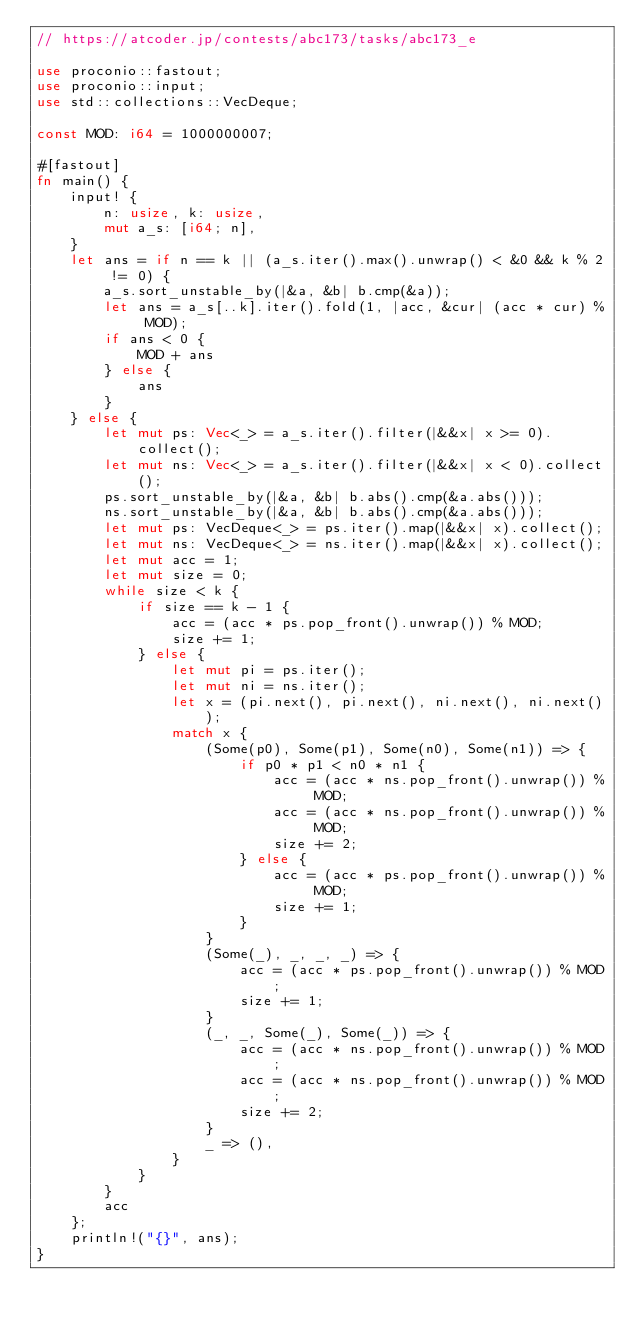<code> <loc_0><loc_0><loc_500><loc_500><_Rust_>// https://atcoder.jp/contests/abc173/tasks/abc173_e

use proconio::fastout;
use proconio::input;
use std::collections::VecDeque;

const MOD: i64 = 1000000007;

#[fastout]
fn main() {
    input! {
        n: usize, k: usize,
        mut a_s: [i64; n],
    }
    let ans = if n == k || (a_s.iter().max().unwrap() < &0 && k % 2 != 0) {
        a_s.sort_unstable_by(|&a, &b| b.cmp(&a));
        let ans = a_s[..k].iter().fold(1, |acc, &cur| (acc * cur) % MOD);
        if ans < 0 {
            MOD + ans
        } else {
            ans
        }
    } else {
        let mut ps: Vec<_> = a_s.iter().filter(|&&x| x >= 0).collect();
        let mut ns: Vec<_> = a_s.iter().filter(|&&x| x < 0).collect();
        ps.sort_unstable_by(|&a, &b| b.abs().cmp(&a.abs()));
        ns.sort_unstable_by(|&a, &b| b.abs().cmp(&a.abs()));
        let mut ps: VecDeque<_> = ps.iter().map(|&&x| x).collect();
        let mut ns: VecDeque<_> = ns.iter().map(|&&x| x).collect();
        let mut acc = 1;
        let mut size = 0;
        while size < k {
            if size == k - 1 {
                acc = (acc * ps.pop_front().unwrap()) % MOD;
                size += 1;
            } else {
                let mut pi = ps.iter();
                let mut ni = ns.iter();
                let x = (pi.next(), pi.next(), ni.next(), ni.next());
                match x {
                    (Some(p0), Some(p1), Some(n0), Some(n1)) => {
                        if p0 * p1 < n0 * n1 {
                            acc = (acc * ns.pop_front().unwrap()) % MOD;
                            acc = (acc * ns.pop_front().unwrap()) % MOD;
                            size += 2;
                        } else {
                            acc = (acc * ps.pop_front().unwrap()) % MOD;
                            size += 1;
                        }
                    }
                    (Some(_), _, _, _) => {
                        acc = (acc * ps.pop_front().unwrap()) % MOD;
                        size += 1;
                    }
                    (_, _, Some(_), Some(_)) => {
                        acc = (acc * ns.pop_front().unwrap()) % MOD;
                        acc = (acc * ns.pop_front().unwrap()) % MOD;
                        size += 2;
                    }
                    _ => (),
                }
            }
        }
        acc
    };
    println!("{}", ans);
}
</code> 